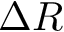Convert formula to latex. <formula><loc_0><loc_0><loc_500><loc_500>\Delta R</formula> 